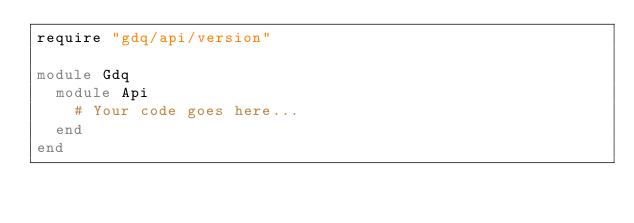<code> <loc_0><loc_0><loc_500><loc_500><_Ruby_>require "gdq/api/version"

module Gdq
  module Api
    # Your code goes here...
  end
end
</code> 